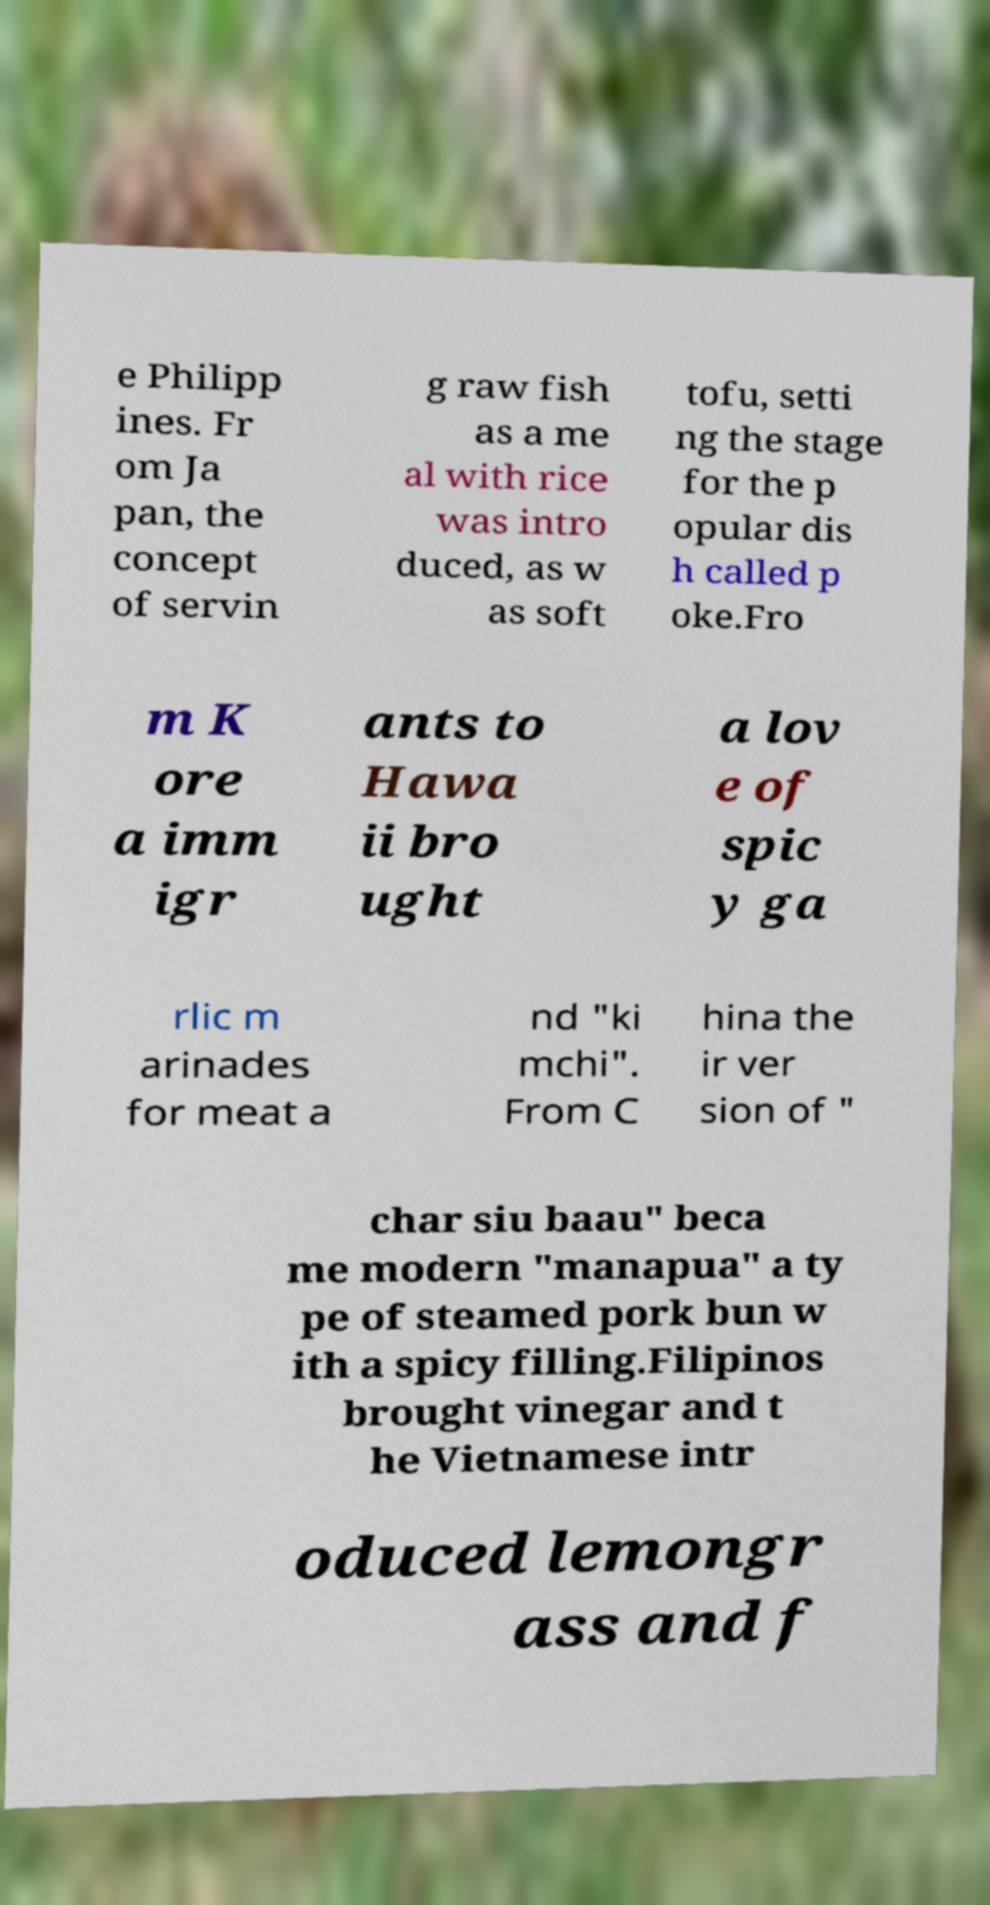Please read and relay the text visible in this image. What does it say? e Philipp ines. Fr om Ja pan, the concept of servin g raw fish as a me al with rice was intro duced, as w as soft tofu, setti ng the stage for the p opular dis h called p oke.Fro m K ore a imm igr ants to Hawa ii bro ught a lov e of spic y ga rlic m arinades for meat a nd "ki mchi". From C hina the ir ver sion of " char siu baau" beca me modern "manapua" a ty pe of steamed pork bun w ith a spicy filling.Filipinos brought vinegar and t he Vietnamese intr oduced lemongr ass and f 